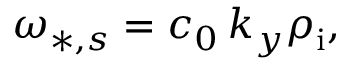<formula> <loc_0><loc_0><loc_500><loc_500>\omega _ { * , s } = c _ { 0 } \, k _ { y } \rho _ { i } ,</formula> 